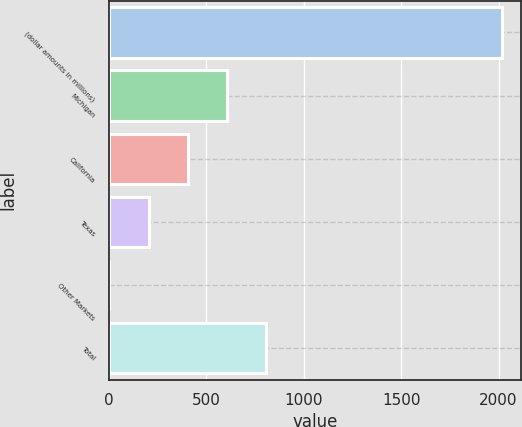<chart> <loc_0><loc_0><loc_500><loc_500><bar_chart><fcel>(dollar amounts in millions)<fcel>Michigan<fcel>California<fcel>Texas<fcel>Other Markets<fcel>Total<nl><fcel>2016<fcel>606.9<fcel>405.6<fcel>204.3<fcel>3<fcel>808.2<nl></chart> 